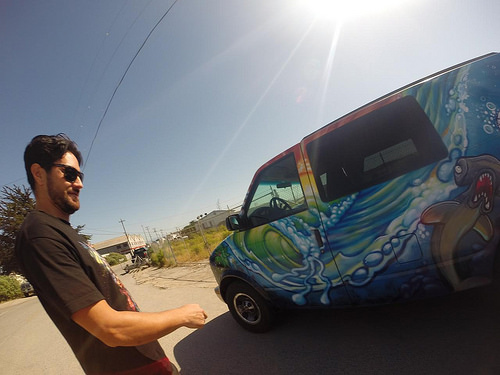<image>
Can you confirm if the man is next to the vehicle? Yes. The man is positioned adjacent to the vehicle, located nearby in the same general area. Where is the van in relation to the sunlight? Is it in front of the sunlight? Yes. The van is positioned in front of the sunlight, appearing closer to the camera viewpoint. 